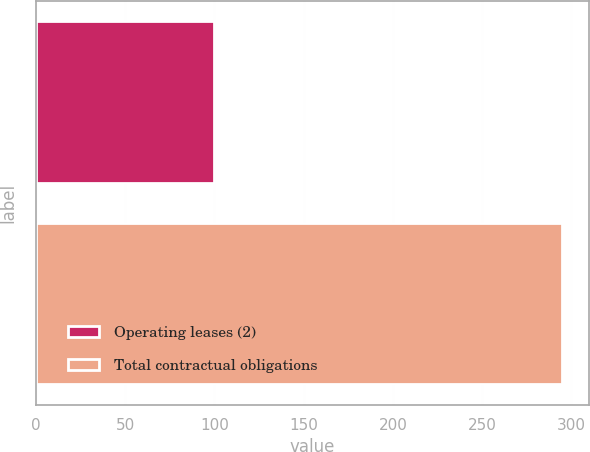<chart> <loc_0><loc_0><loc_500><loc_500><bar_chart><fcel>Operating leases (2)<fcel>Total contractual obligations<nl><fcel>100<fcel>295<nl></chart> 